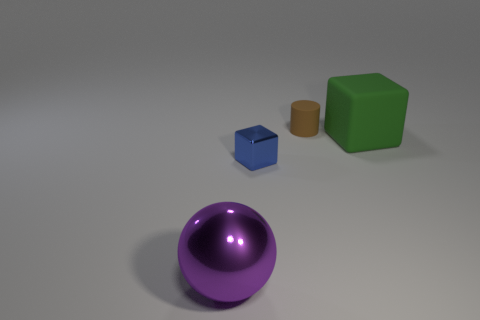What color is the rubber cylinder that is the same size as the blue block?
Give a very brief answer. Brown. There is a metallic object behind the thing on the left side of the tiny block; what color is it?
Keep it short and to the point. Blue. There is a metallic object that is behind the big thing in front of the metal object to the right of the sphere; what is its shape?
Your answer should be compact. Cube. There is a thing right of the tiny cylinder; how many purple shiny spheres are behind it?
Keep it short and to the point. 0. Are the small block and the tiny cylinder made of the same material?
Offer a very short reply. No. How many brown rubber cylinders are left of the small thing that is in front of the tiny thing behind the matte block?
Make the answer very short. 0. What is the color of the large object on the left side of the small metal cube?
Your answer should be compact. Purple. There is a tiny object that is behind the big object right of the purple object; what is its shape?
Offer a terse response. Cylinder. How many cylinders are either green things or rubber objects?
Your response must be concise. 1. The thing that is in front of the rubber cylinder and behind the blue metal thing is made of what material?
Ensure brevity in your answer.  Rubber. 